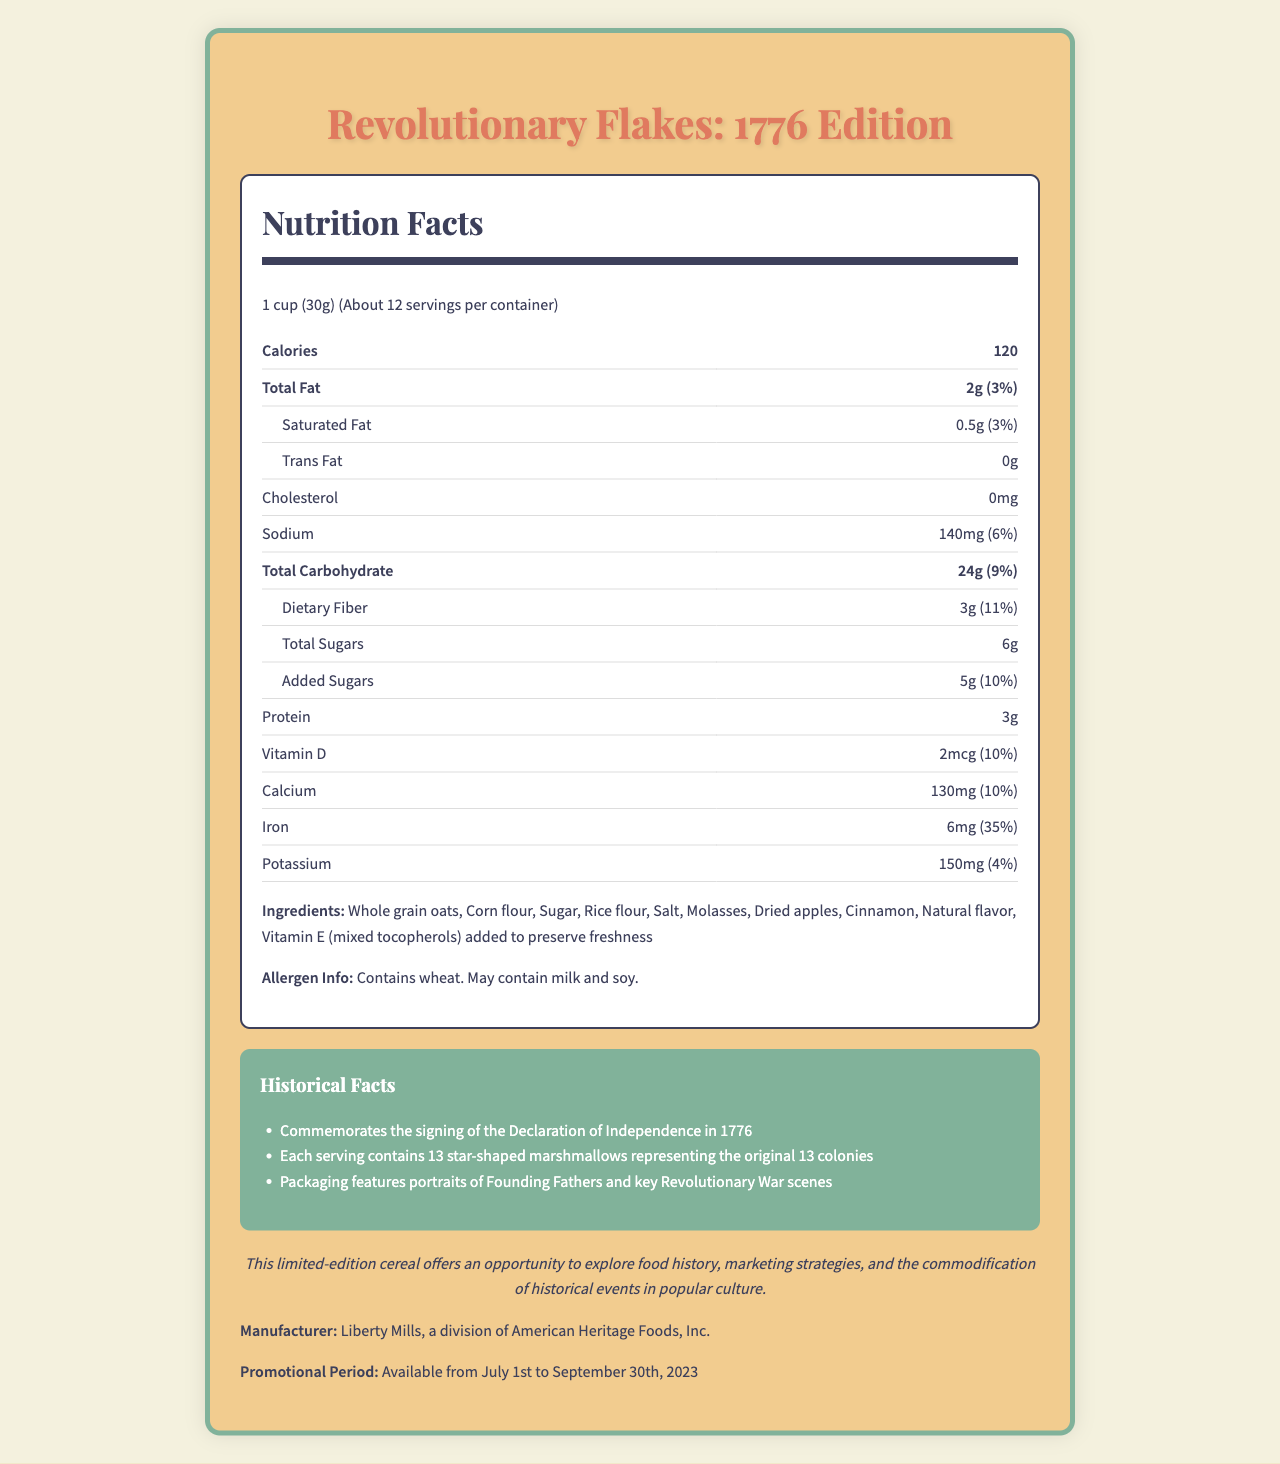what is the serving size? The serving size is mentioned at the top of the Nutrition Facts section as "1 cup (30g)."
Answer: 1 cup (30g) how many calories are in one serving? The number of calories per serving is listed at the top of the Nutrition Facts under Calories.
Answer: 120 what percentage of the daily value does iron contribute per serving? The daily value percentage for iron is provided in the Nutrition Facts section as "6mg (35%)."
Answer: 35% what is the total fat content per serving? The total fat content is listed in the Nutrition Facts section as "Total Fat 2g."
Answer: 2g what are the historical facts mentioned about the cereal? The historical facts are described in a dedicated section titled "Historical Facts."
Answer: Commemorates the signing of the Declaration of Independence in 1776; Each serving contains 13 star-shaped marshmallows representing the original 13 colonies; Packaging features portraits of Founding Fathers and key Revolutionary War scenes what ingredients are in the cereal? The list of ingredients is found under the Ingredients section in the document.
Answer: Whole grain oats, Corn flour, Sugar, Rice flour, Salt, Molasses, Dried apples, Cinnamon, Natural flavor, Vitamin E (mixed tocopherols) added to preserve freshness when is the promotional period for the cereal? The promotional period is stated at the bottom of the document.
Answer: Available from July 1st to September 30th, 2023 how much dietary fiber is in one serving? Dietary fiber per serving is listed in the Nutrition Facts as "Dietary Fiber 3g."
Answer: 3g what vitamin is included in the cereal and what is its daily value percentage? A. Vitamin A - 15% B. Vitamin C - 0% C. Vitamin D - 10% D. Vitamin E - 5% The Nutrition Facts section lists Vitamin D with an amount of 2mcg and a daily value of 10%.
Answer: C what is the sodium content per serving? The Nutrition Facts section lists the sodium amount as "140mg."
Answer: 140mg does the cereal contain trans fat? The Nutrition Facts section clearly lists trans fat as "0g."
Answer: No summarize the main idea of the document. The document presents the nutritional facts, ingredients, and historical significance of the limited-edition cereal, along with its promotional period and academic relevance.
Answer: The document provides detailed nutrition information for Revolutionary Flakes: 1776 Edition cereal, commemorating the signing of the Declaration of Independence with unique historical features and clear nutritional details. who manufactures Revolutionary Flakes: 1776 Edition? The manufacturer is mentioned at the bottom of the document.
Answer: Liberty Mills, a division of American Heritage Foods, Inc. what is the academic tie-in mentioned in the document? The academic tie-in is stated in a dedicated section and explains how this product can be used for educational purposes.
Answer: The limited-edition cereal offers an opportunity to explore food history, marketing strategies, and the commodification of historical events in popular culture. is there any allergen information provided for the cereal? The document mentions allergen information saying, "Contains wheat. May contain milk and soy."
Answer: Yes what historical event does the cereal commemorate? This information is listed in the Historical Facts section.
Answer: The signing of the Declaration of Independence in 1776 what is the total carbohydrate content and its daily value percentage? The Nutrition Facts section lists "Total Carbohydrate 24g (9%)."
Answer: 24g (9%) how many servings are there per container? The serving size section states the approximate number of servings per container.
Answer: About 12 what is the promotion strategy for the cereal? The document does not provide detailed information about the promotion strategy beyond the promotional period and historical theme.
Answer: Not enough information 